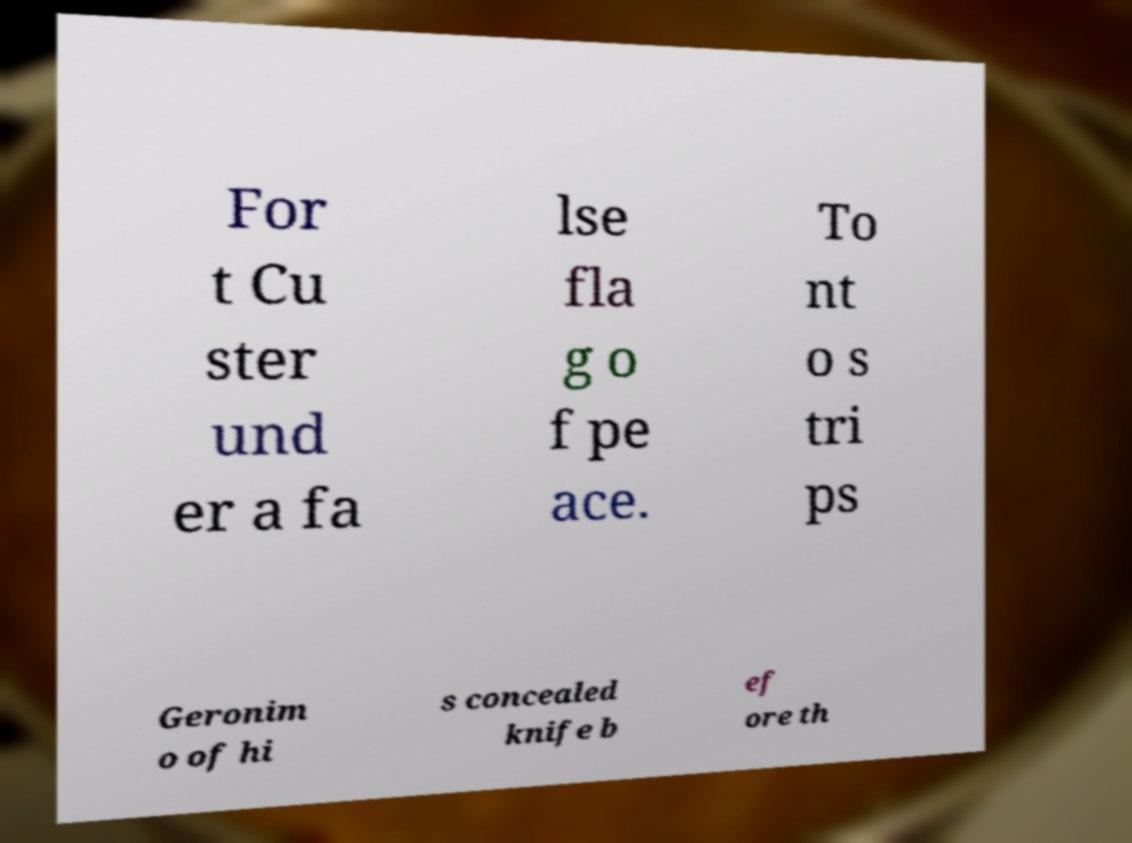I need the written content from this picture converted into text. Can you do that? For t Cu ster und er a fa lse fla g o f pe ace. To nt o s tri ps Geronim o of hi s concealed knife b ef ore th 